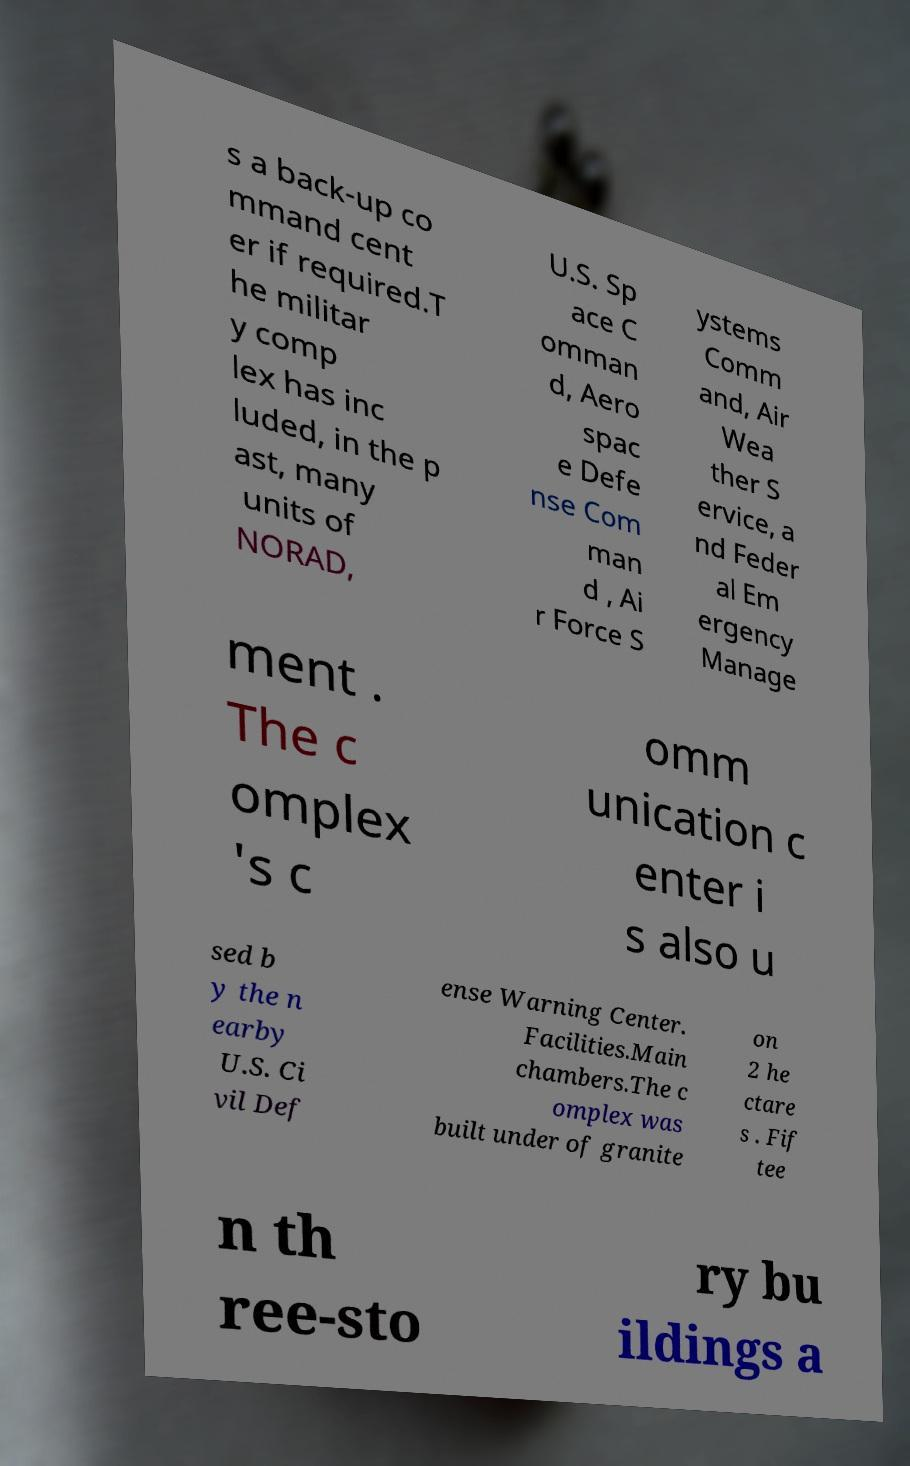Can you read and provide the text displayed in the image?This photo seems to have some interesting text. Can you extract and type it out for me? s a back-up co mmand cent er if required.T he militar y comp lex has inc luded, in the p ast, many units of NORAD, U.S. Sp ace C omman d, Aero spac e Defe nse Com man d , Ai r Force S ystems Comm and, Air Wea ther S ervice, a nd Feder al Em ergency Manage ment . The c omplex 's c omm unication c enter i s also u sed b y the n earby U.S. Ci vil Def ense Warning Center. Facilities.Main chambers.The c omplex was built under of granite on 2 he ctare s . Fif tee n th ree-sto ry bu ildings a 